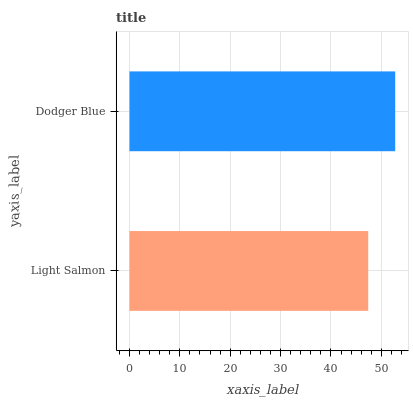Is Light Salmon the minimum?
Answer yes or no. Yes. Is Dodger Blue the maximum?
Answer yes or no. Yes. Is Dodger Blue the minimum?
Answer yes or no. No. Is Dodger Blue greater than Light Salmon?
Answer yes or no. Yes. Is Light Salmon less than Dodger Blue?
Answer yes or no. Yes. Is Light Salmon greater than Dodger Blue?
Answer yes or no. No. Is Dodger Blue less than Light Salmon?
Answer yes or no. No. Is Dodger Blue the high median?
Answer yes or no. Yes. Is Light Salmon the low median?
Answer yes or no. Yes. Is Light Salmon the high median?
Answer yes or no. No. Is Dodger Blue the low median?
Answer yes or no. No. 